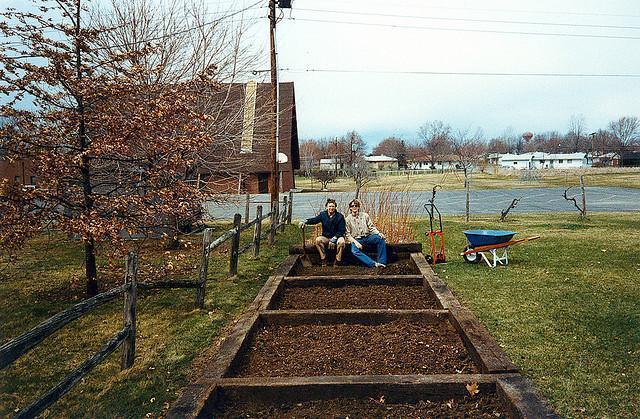How many people do you see?
Give a very brief answer. 2. How many black cars are there?
Give a very brief answer. 0. 